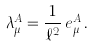<formula> <loc_0><loc_0><loc_500><loc_500>\lambda _ { \mu } ^ { A } = \frac { 1 } { \ell ^ { 2 } } \, e _ { \mu } ^ { A } \, .</formula> 